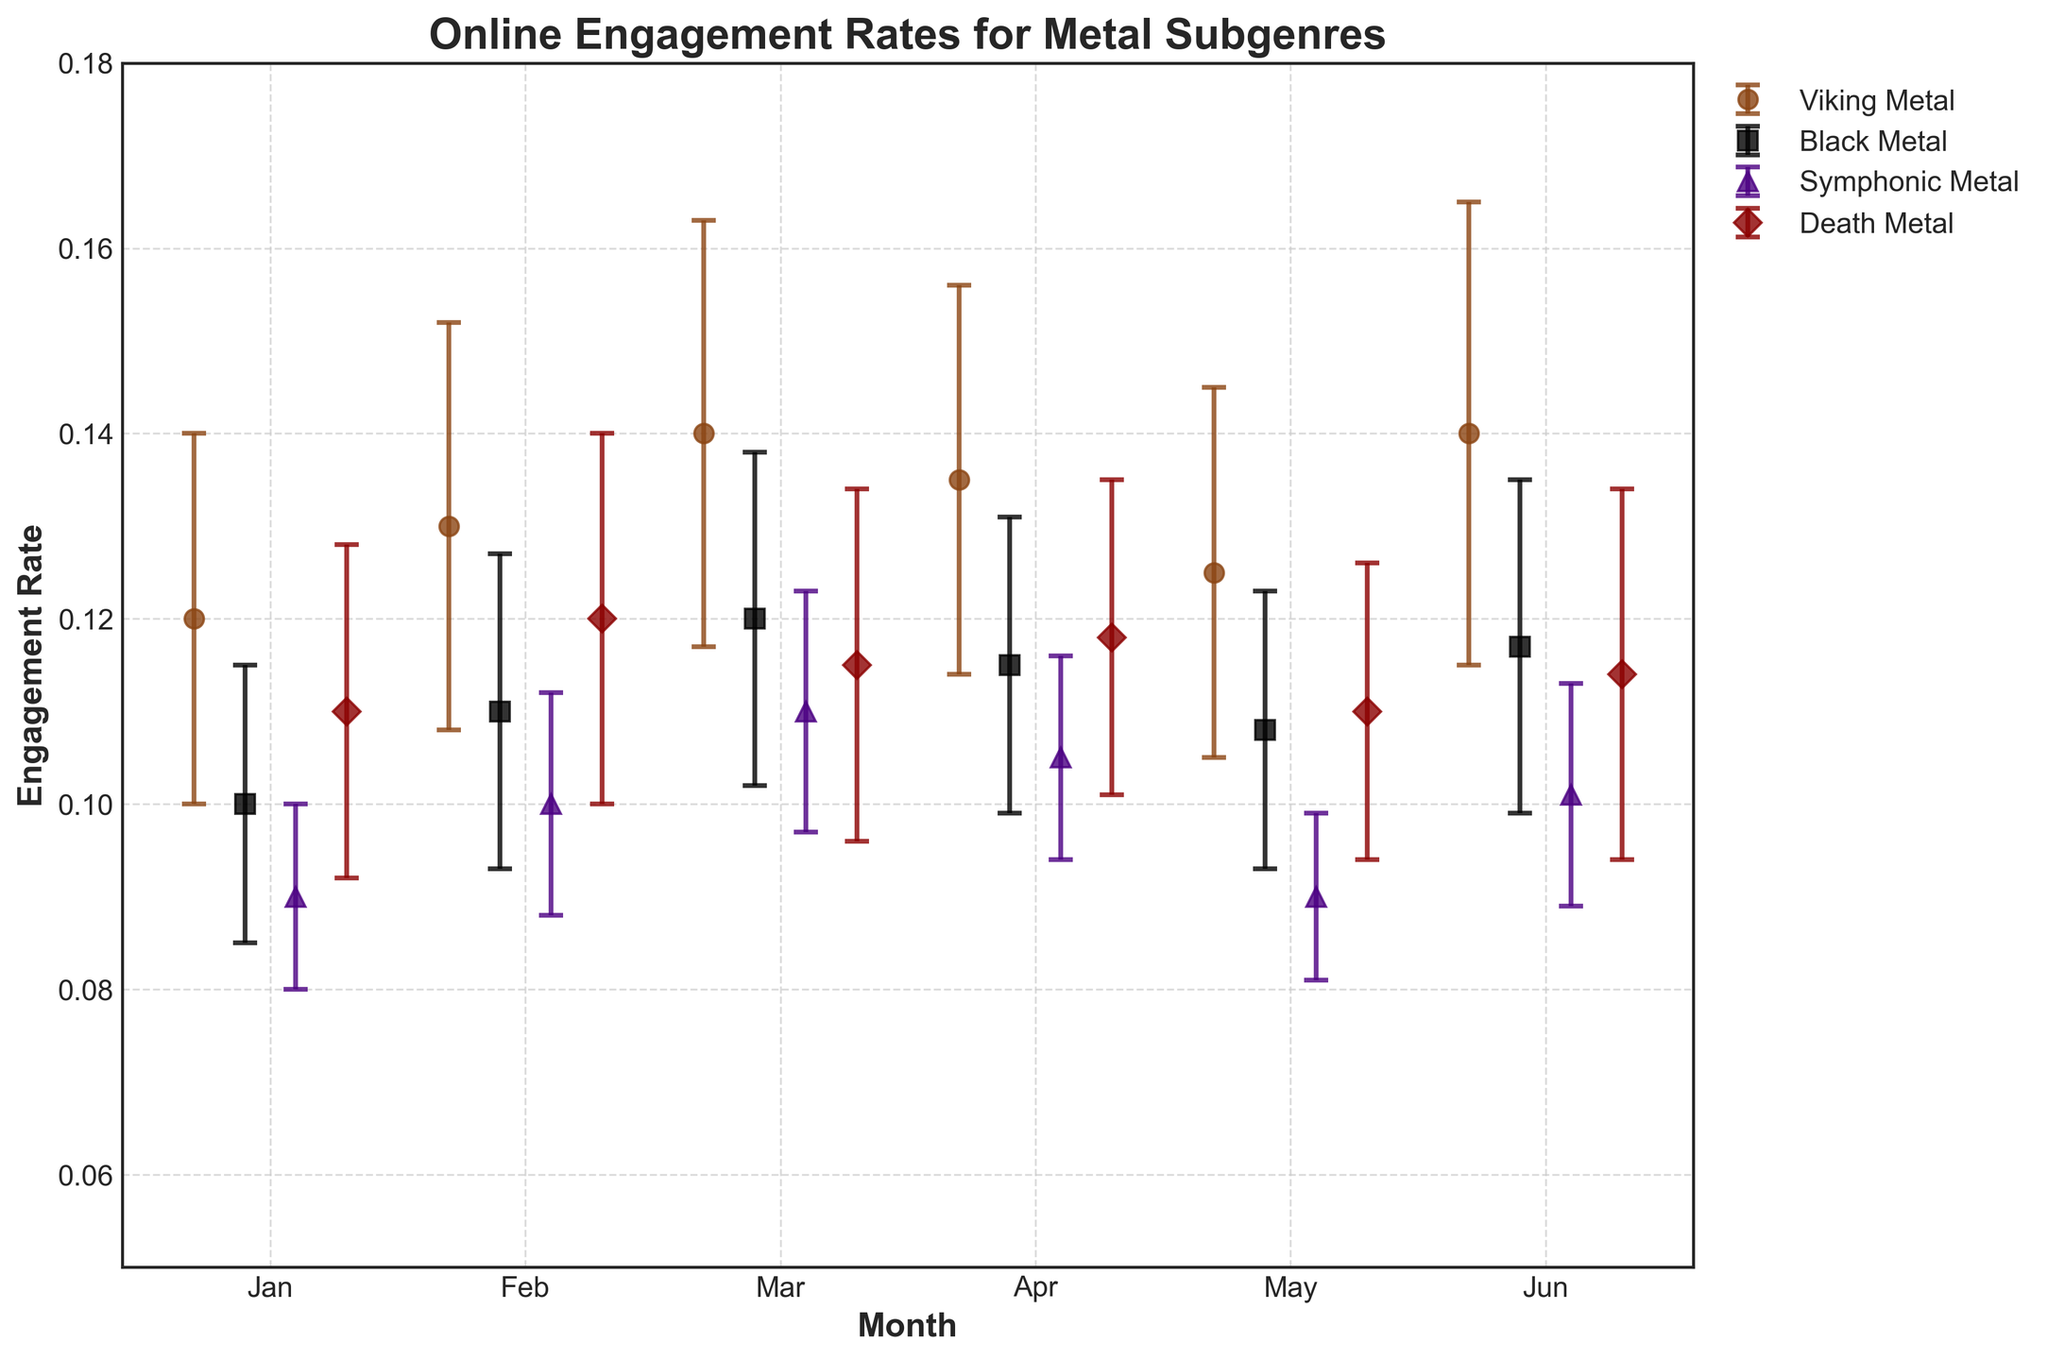What's the title of the plot? The title of a plot is usually located at the top center of the plot. This plot has the title "Online Engagement Rates for Metal Subgenres".
Answer: Online Engagement Rates for Metal Subgenres Which subgenre has the highest engagement rate in June? To answer this, look at the June data points for each subgenre and compare the engagement rates. Viking Metal shows the highest rate for June.
Answer: Viking Metal What is the engagement rate of Symphonic Metal in April? Find the Symphonic Metal data point for April and read off the engagement rate. From the plot, it is 0.105.
Answer: 0.105 Which month shows the largest increase in engagement rate for Black Metal compared to the previous month? Compare the engagement rates for Black Metal from month to month: January vs. February (0.01), February vs. March (0.01), March vs. April (-0.005), April vs. May (-0.007), and May vs. June (0.009). The largest increase is February to March.
Answer: February to March What is the average engagement rate of Death Metal over the six months? Sum the engagement rates for Death Metal across all months and divide by the number of months: (0.11 + 0.12 + 0.115 + 0.118 + 0.11 + 0.114) / 6 = 0.1145.
Answer: 0.1145 Which subgenre has the smallest standard deviation in engagement rate? Compare the standard deviations across all subgenres and months to find the smallest value. Symphonic Metal in May has the smallest standard deviation of 0.009.
Answer: Symphonic Metal in May How does the engagement rate of Viking Metal in January compare to Black Metal in March? Find and compare the engagement rates: Viking Metal in January is 0.12 and Black Metal in March is 0.12. Both are equal.
Answer: Equal What is the difference in engagement rate between Symphonic Metal and Death Metal in March? Subtract the March engagement rate of Symphonic Metal from that of Death Metal: 0.115 - 0.11 = 0.005.
Answer: 0.005 Which subgenre has the most consistent engagement rate (smallest variation) over the months? Find the subgenre with the smallest range between its highest and lowest engagement rates across all the months. Symphonic Metal ranges from 0.09 to 0.105, with a difference of 0.015, which is the smallest range.
Answer: Symphonic Metal What can you infer about the overall trend in engagement rates for Viking Metal from January to June? Look for the overall pattern in the engagement rates of Viking Metal: it starts at 0.12 in January, peaks at 0.14 in March and June, showing an upward trend with some fluctuations.
Answer: Upward trend 